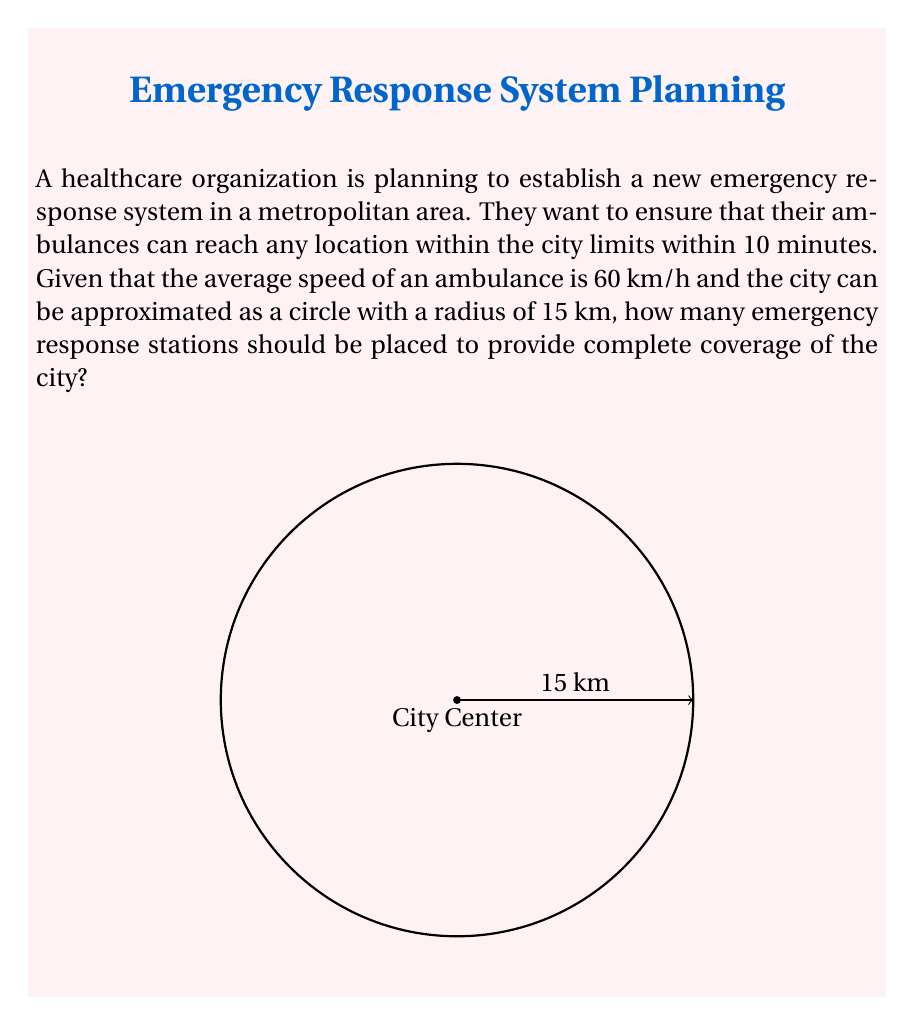Provide a solution to this math problem. Let's approach this problem step-by-step:

1) First, we need to calculate the distance an ambulance can travel in 10 minutes:
   $$ \text{Distance} = \text{Speed} \times \text{Time} $$
   $$ \text{Distance} = 60 \text{ km/h} \times \frac{10}{60} \text{ h} = 10 \text{ km} $$

2) This means each emergency response station can cover a circular area with a radius of 10 km.

3) We can model each station's coverage as a circle with equation:
   $$ (x-h)^2 + (y-k)^2 = 10^2 $$
   where $(h,k)$ is the center of the circle (location of the station).

4) To cover the entire city, we need to find how many of these 10 km radius circles can fit within the 15 km radius city circle.

5) The area of the city is:
   $$ A_{\text{city}} = \pi r^2 = \pi (15)^2 = 225\pi \text{ km}^2 $$

6) The area covered by each station is:
   $$ A_{\text{station}} = \pi r^2 = \pi (10)^2 = 100\pi \text{ km}^2 $$

7) The number of stations needed is:
   $$ \text{Number of stations} = \ceil{\frac{A_{\text{city}}}{A_{\text{station}}}} = \ceil{\frac{225\pi}{100\pi}} = \ceil{2.25} = 3 $$

   We use the ceiling function because we need to ensure complete coverage, so we round up to the nearest whole number.

Therefore, at least 3 emergency response stations should be placed to provide complete coverage of the city.
Answer: 3 stations 